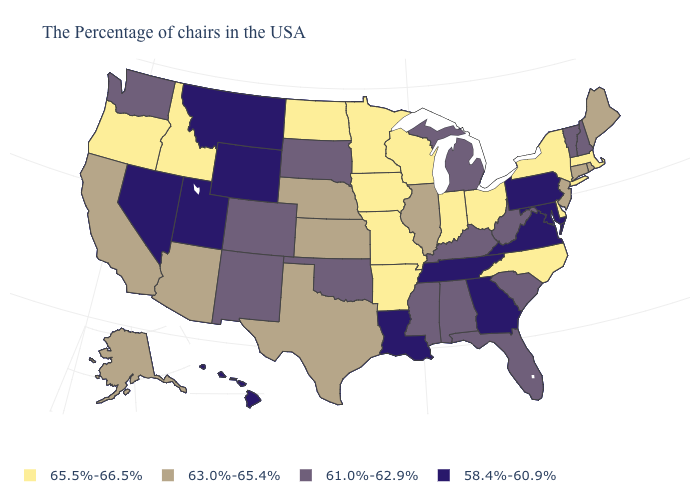What is the highest value in the West ?
Short answer required. 65.5%-66.5%. What is the value of Montana?
Short answer required. 58.4%-60.9%. Does the first symbol in the legend represent the smallest category?
Be succinct. No. What is the lowest value in states that border Virginia?
Give a very brief answer. 58.4%-60.9%. Name the states that have a value in the range 58.4%-60.9%?
Answer briefly. Maryland, Pennsylvania, Virginia, Georgia, Tennessee, Louisiana, Wyoming, Utah, Montana, Nevada, Hawaii. What is the value of North Dakota?
Write a very short answer. 65.5%-66.5%. What is the value of Alabama?
Short answer required. 61.0%-62.9%. Does Nebraska have a higher value than Kansas?
Write a very short answer. No. What is the value of Idaho?
Be succinct. 65.5%-66.5%. Name the states that have a value in the range 58.4%-60.9%?
Be succinct. Maryland, Pennsylvania, Virginia, Georgia, Tennessee, Louisiana, Wyoming, Utah, Montana, Nevada, Hawaii. Does New Hampshire have the same value as Kentucky?
Quick response, please. Yes. Does Alaska have the highest value in the USA?
Be succinct. No. Among the states that border Kansas , does Nebraska have the lowest value?
Be succinct. No. Name the states that have a value in the range 65.5%-66.5%?
Keep it brief. Massachusetts, New York, Delaware, North Carolina, Ohio, Indiana, Wisconsin, Missouri, Arkansas, Minnesota, Iowa, North Dakota, Idaho, Oregon. Among the states that border Wyoming , does Colorado have the lowest value?
Give a very brief answer. No. 